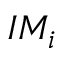Convert formula to latex. <formula><loc_0><loc_0><loc_500><loc_500>I M _ { i }</formula> 